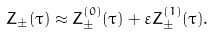Convert formula to latex. <formula><loc_0><loc_0><loc_500><loc_500>Z _ { \pm } ( \tau ) \approx Z _ { \pm } ^ { ( 0 ) } ( \tau ) + \varepsilon Z _ { \pm } ^ { ( 1 ) } ( \tau ) .</formula> 